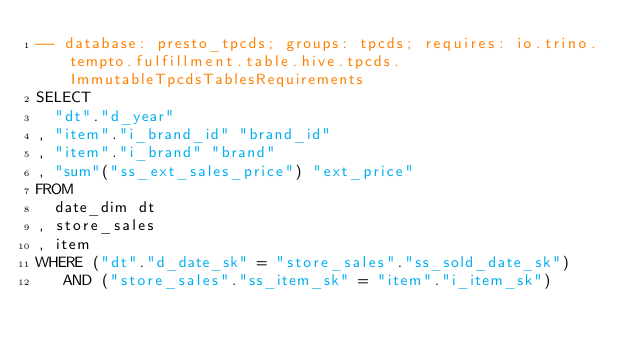<code> <loc_0><loc_0><loc_500><loc_500><_SQL_>-- database: presto_tpcds; groups: tpcds; requires: io.trino.tempto.fulfillment.table.hive.tpcds.ImmutableTpcdsTablesRequirements
SELECT
  "dt"."d_year"
, "item"."i_brand_id" "brand_id"
, "item"."i_brand" "brand"
, "sum"("ss_ext_sales_price") "ext_price"
FROM
  date_dim dt
, store_sales
, item
WHERE ("dt"."d_date_sk" = "store_sales"."ss_sold_date_sk")
   AND ("store_sales"."ss_item_sk" = "item"."i_item_sk")</code> 